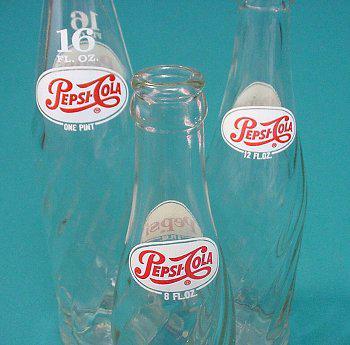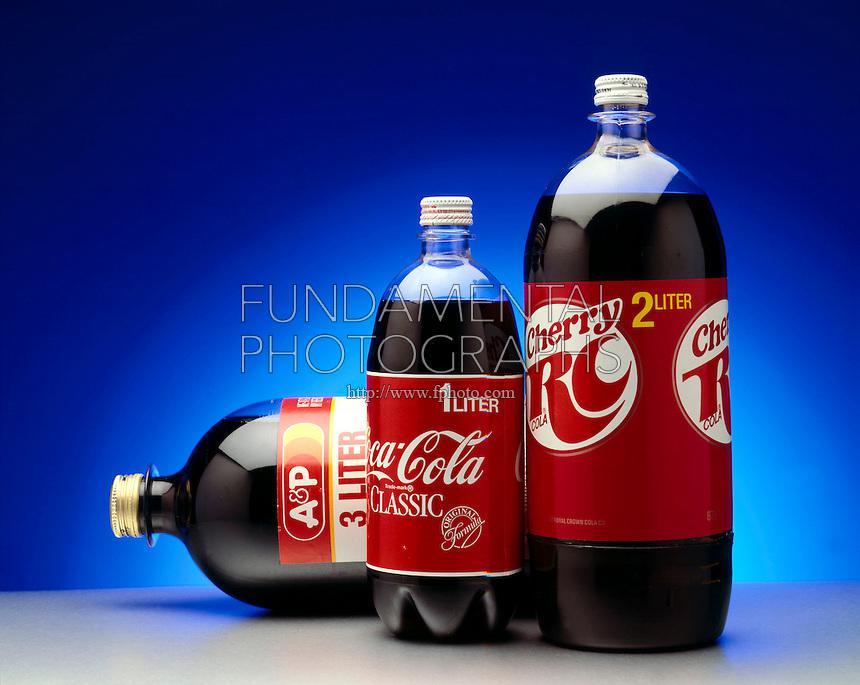The first image is the image on the left, the second image is the image on the right. Given the left and right images, does the statement "There are the same number of bottles in each of the images." hold true? Answer yes or no. Yes. The first image is the image on the left, the second image is the image on the right. Examine the images to the left and right. Is the description "There is a total of six bottles" accurate? Answer yes or no. Yes. 